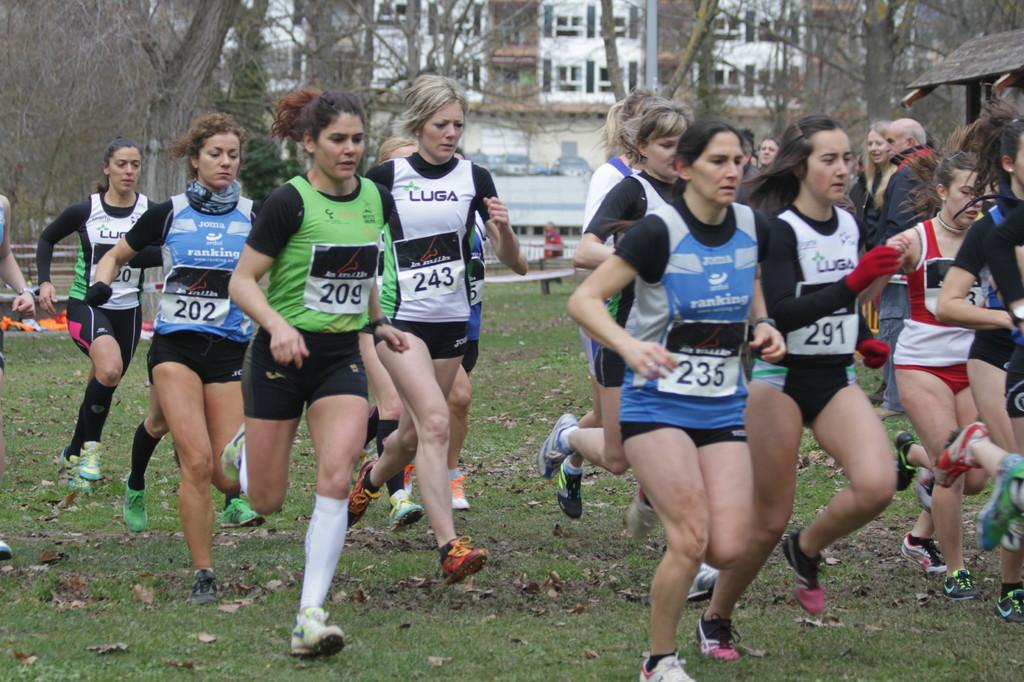What is the bib number on the runner in green?
Give a very brief answer. 209. What is the bib number on the first runner in blue?
Keep it short and to the point. 235. 